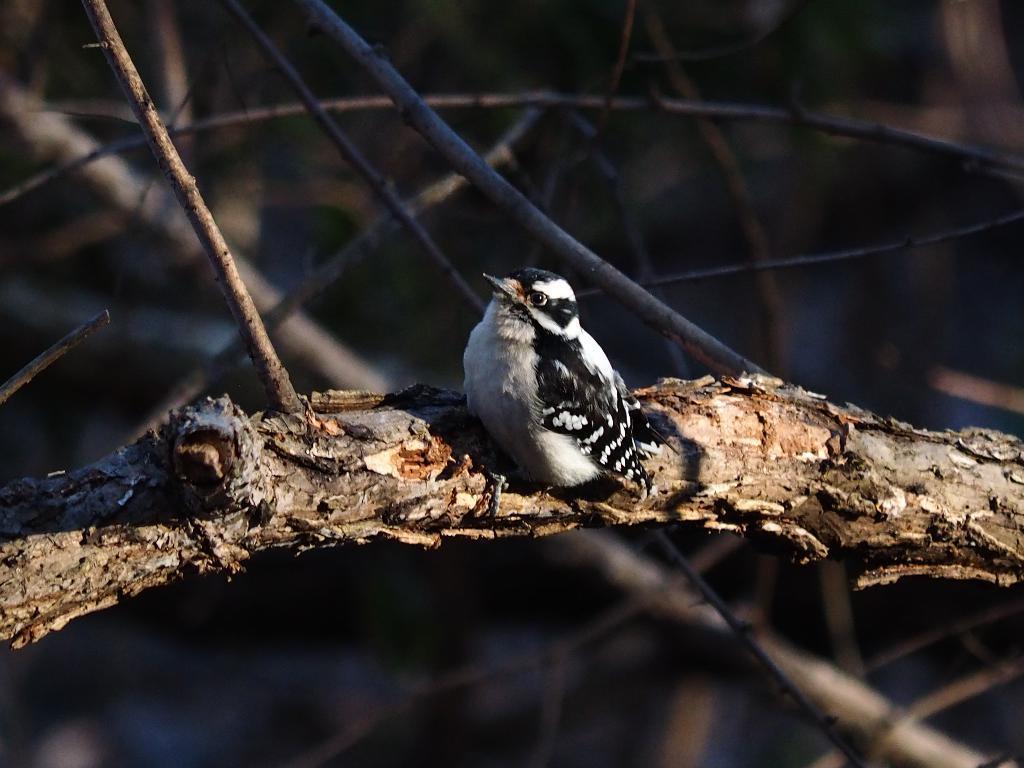How would you summarize this image in a sentence or two? We can see bird on wooden surface and we can see wooden sticks. In the background it is blur. 